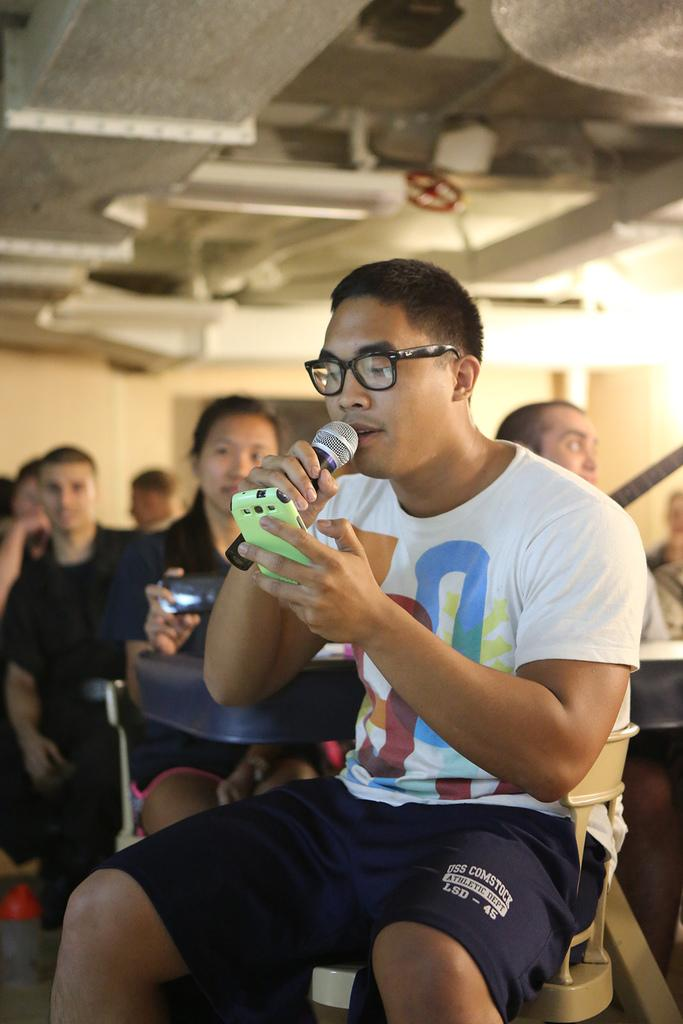What is the person in the image doing? The person is sitting in a chair and holding a microphone. What else is the person holding in the image? The person is also holding a mobile. What can be seen in the background of the image? There is a group of people in the background of the image. Can you describe the lighting in the image? Yes, there is light visible in the image. What type of cover is being used to protect the sand in the image? There is no cover or sand present in the image; it features a person sitting in a chair holding a microphone and mobile, with a group of people in the background and visible light. 